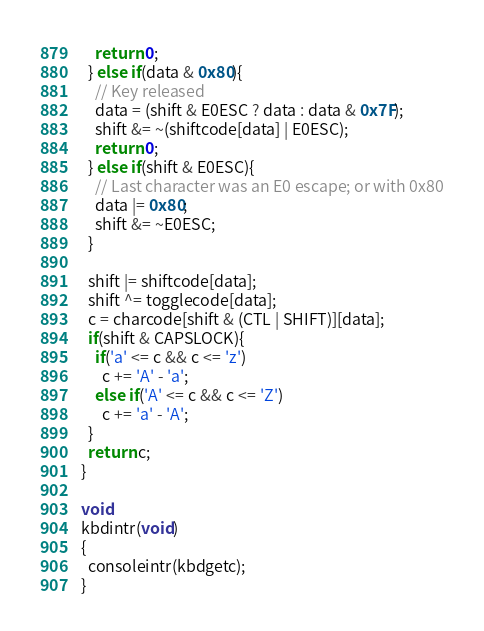Convert code to text. <code><loc_0><loc_0><loc_500><loc_500><_C_>    return 0;
  } else if(data & 0x80){
    // Key released
    data = (shift & E0ESC ? data : data & 0x7F);
    shift &= ~(shiftcode[data] | E0ESC);
    return 0;
  } else if(shift & E0ESC){
    // Last character was an E0 escape; or with 0x80
    data |= 0x80;
    shift &= ~E0ESC;
  }

  shift |= shiftcode[data];
  shift ^= togglecode[data];
  c = charcode[shift & (CTL | SHIFT)][data];
  if(shift & CAPSLOCK){
    if('a' <= c && c <= 'z')
      c += 'A' - 'a';
    else if('A' <= c && c <= 'Z')
      c += 'a' - 'A';
  }
  return c;
}

void
kbdintr(void)
{
  consoleintr(kbdgetc);
}
</code> 